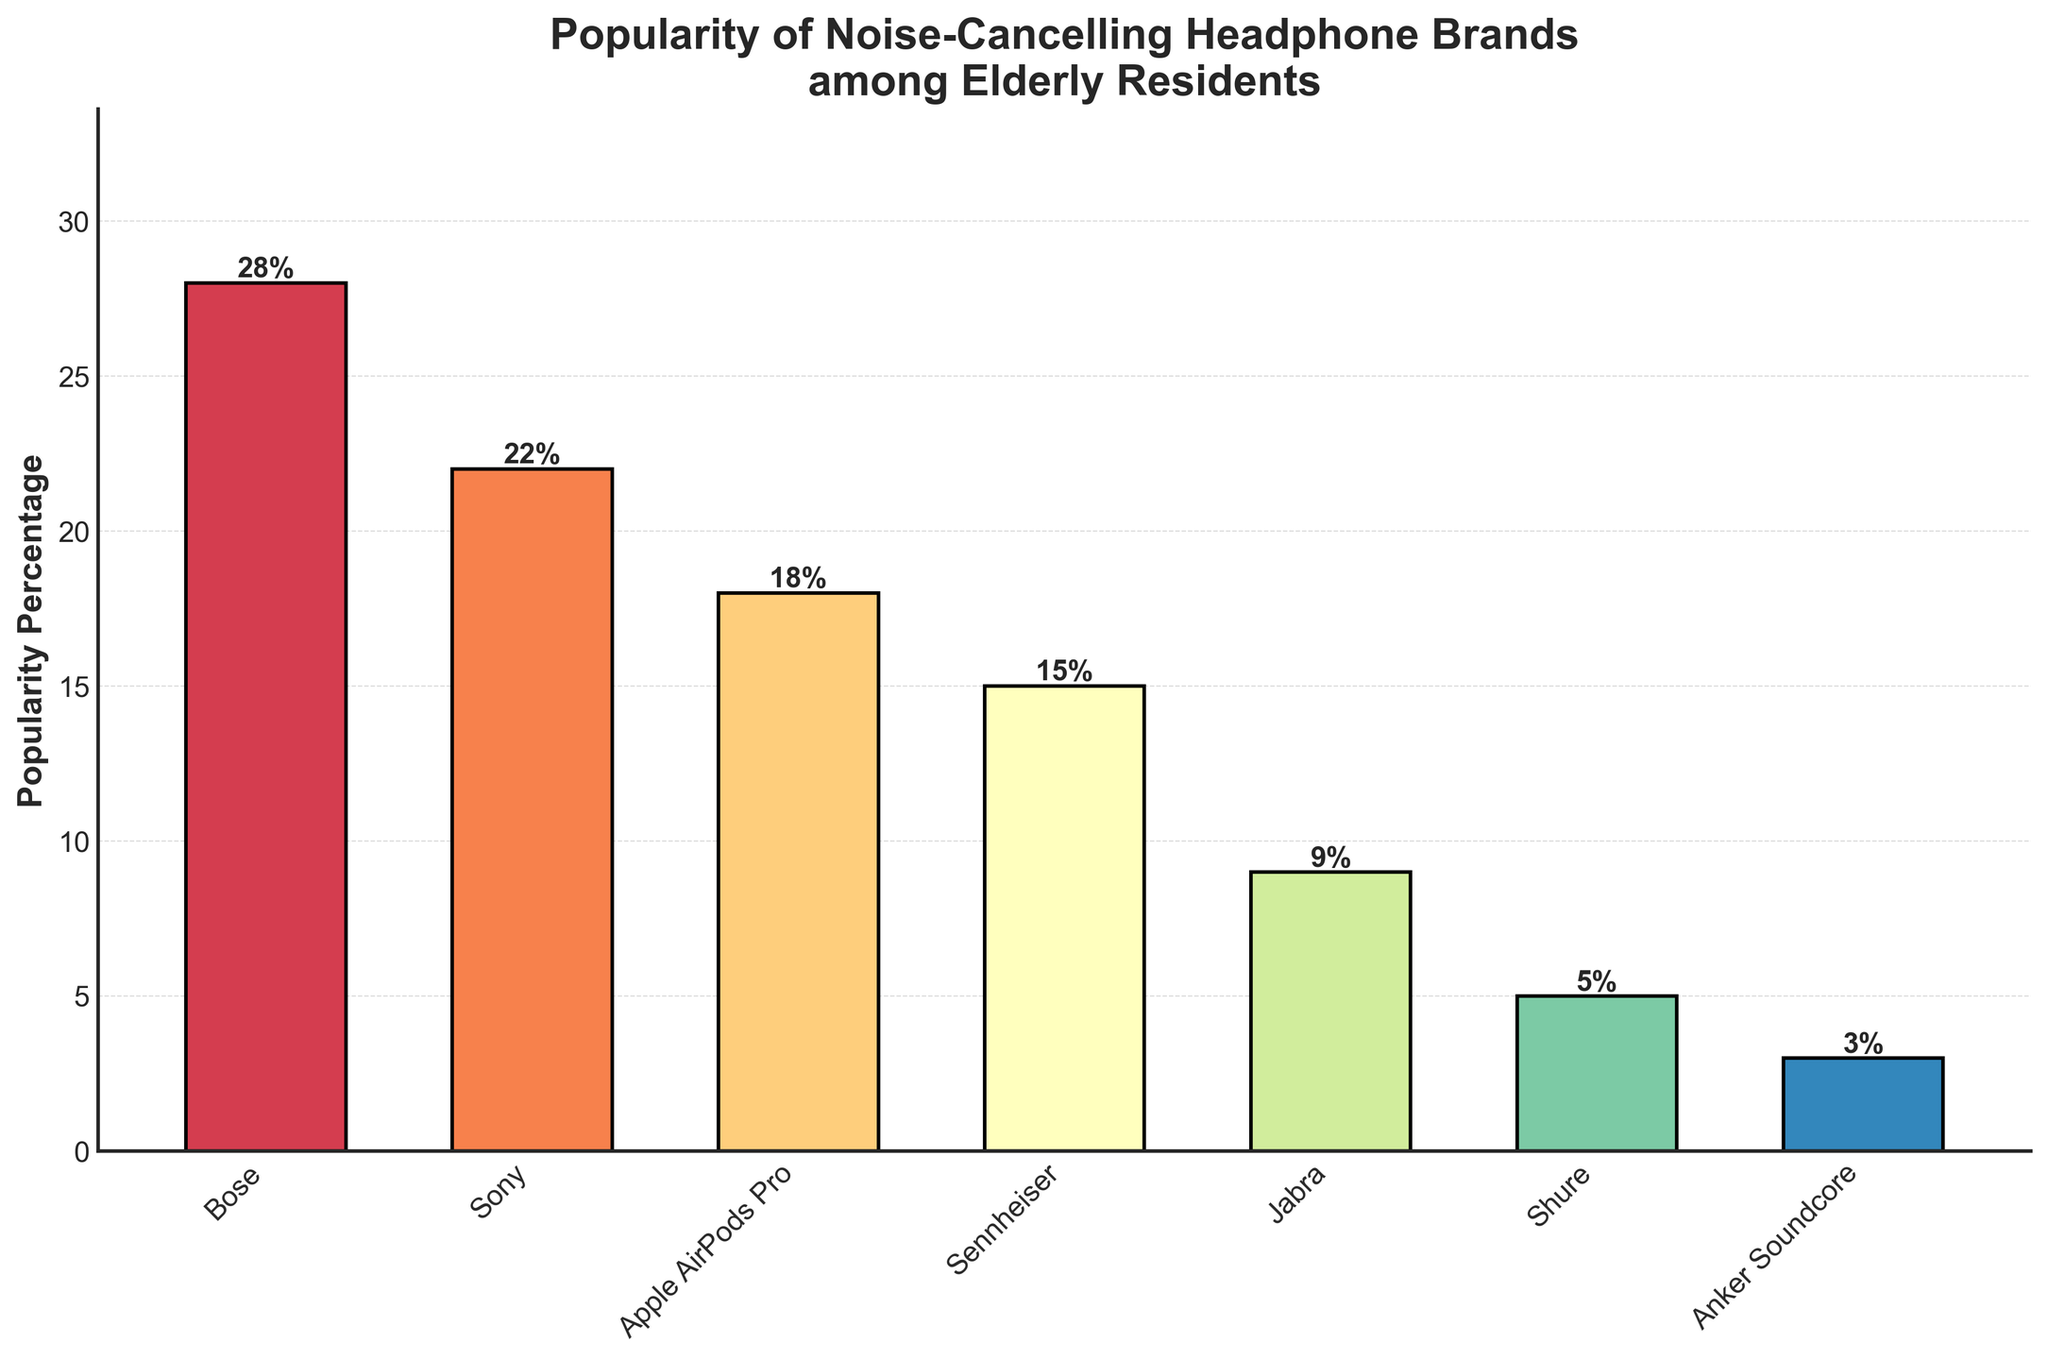How many brands have a popularity percentage above 20%? From the bar chart, Bose has 28% and Sony has 22%. These are the only brands above 20%.
Answer: 2 Which brand is the least popular? The smallest bar corresponds to Anker Soundcore with a popularity percentage of 3%.
Answer: Anker Soundcore What is the combined popularity percentage of Apple AirPods Pro and Jabra? Apple AirPods Pro has 18% and Jabra has 9%. Adding these gives 18% + 9% = 27%.
Answer: 27% Which are the top three most popular brands? The three tallest bars correspond to Bose, Sony, and Apple AirPods Pro with popularity percentages of 28%, 22%, and 18%, respectively.
Answer: Bose, Sony, Apple AirPods Pro By how much is Bose more popular than Sennheiser? Bose has 28% and Sennheiser has 15%. The difference is 28% - 15% = 13%.
Answer: 13% Are Sennheiser and Jabra combined more popular than Apple AirPods Pro? Sennheiser has 15% and Jabra has 9%. Combined, they are 15% + 9% = 24%, which is greater than Apple AirPods Pro's 18%.
Answer: Yes Order the brands from most to least popular. The brands ordered by decreasing popularity: Bose (28%), Sony (22%), Apple AirPods Pro (18%), Sennheiser (15%), Jabra (9%), Shure (5%), Anker Soundcore (3%).
Answer: Bose, Sony, Apple AirPods Pro, Sennheiser, Jabra, Shure, Anker Soundcore If half of the Apple AirPods Pro users switch to Bose, what will Bose's new popularity percentage be? Half of Apple AirPods Pro's 18% is 9%. Adding this to Bose's 28% gives 28% + 9% = 37%.
Answer: 37% What is the average popularity percentage of all the brands? Sum the percentages: 28% + 22% + 18% + 15% + 9% + 5% + 3% = 100%. There are 7 brands, so the average is 100%/7 ≈ 14.29%.
Answer: 14.29% Which brand has a popularity percentage closest to the median value? Ordering the popularity percentages, we get: 3%, 5%, 9%, 15%, 18%, 22%, 28%. The median value is the fourth value, which is 15%, corresponding to Sennheiser.
Answer: Sennheiser 